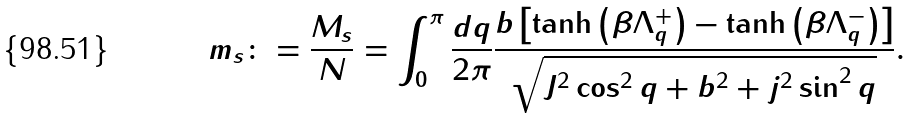Convert formula to latex. <formula><loc_0><loc_0><loc_500><loc_500>m _ { s } \colon = \frac { M _ { s } } { N } = \int _ { 0 } ^ { \pi } \frac { d q } { 2 \pi } \frac { b \left [ \tanh \left ( \beta \Lambda _ { q } ^ { + } \right ) - \tanh \left ( \beta \Lambda _ { q } ^ { - } \right ) \right ] } { \sqrt { J ^ { 2 } \cos ^ { 2 } q + b ^ { 2 } + j ^ { 2 } \sin ^ { 2 } q } } .</formula> 